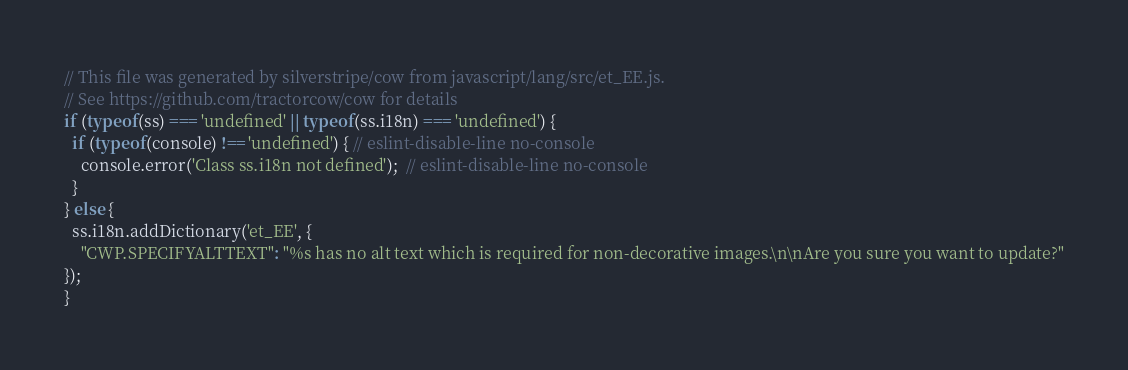<code> <loc_0><loc_0><loc_500><loc_500><_JavaScript_>// This file was generated by silverstripe/cow from javascript/lang/src/et_EE.js.
// See https://github.com/tractorcow/cow for details
if (typeof(ss) === 'undefined' || typeof(ss.i18n) === 'undefined') {
  if (typeof(console) !== 'undefined') { // eslint-disable-line no-console
    console.error('Class ss.i18n not defined');  // eslint-disable-line no-console
  }
} else {
  ss.i18n.addDictionary('et_EE', {
    "CWP.SPECIFYALTTEXT": "%s has no alt text which is required for non-decorative images.\n\nAre you sure you want to update?"
});
}</code> 